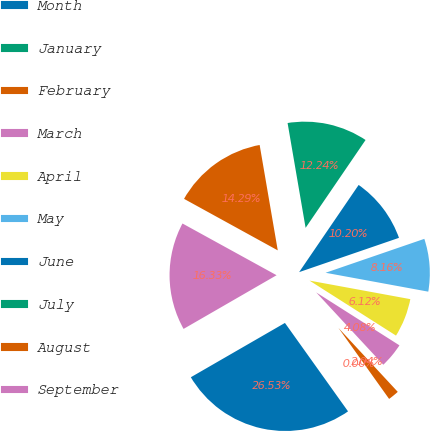<chart> <loc_0><loc_0><loc_500><loc_500><pie_chart><fcel>Month<fcel>January<fcel>February<fcel>March<fcel>April<fcel>May<fcel>June<fcel>July<fcel>August<fcel>September<nl><fcel>26.53%<fcel>0.0%<fcel>2.04%<fcel>4.08%<fcel>6.12%<fcel>8.16%<fcel>10.2%<fcel>12.24%<fcel>14.29%<fcel>16.33%<nl></chart> 